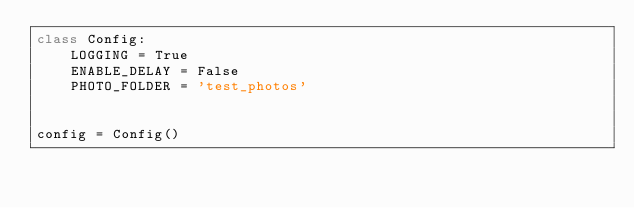<code> <loc_0><loc_0><loc_500><loc_500><_Python_>class Config:
    LOGGING = True
    ENABLE_DELAY = False
    PHOTO_FOLDER = 'test_photos'


config = Config()
</code> 